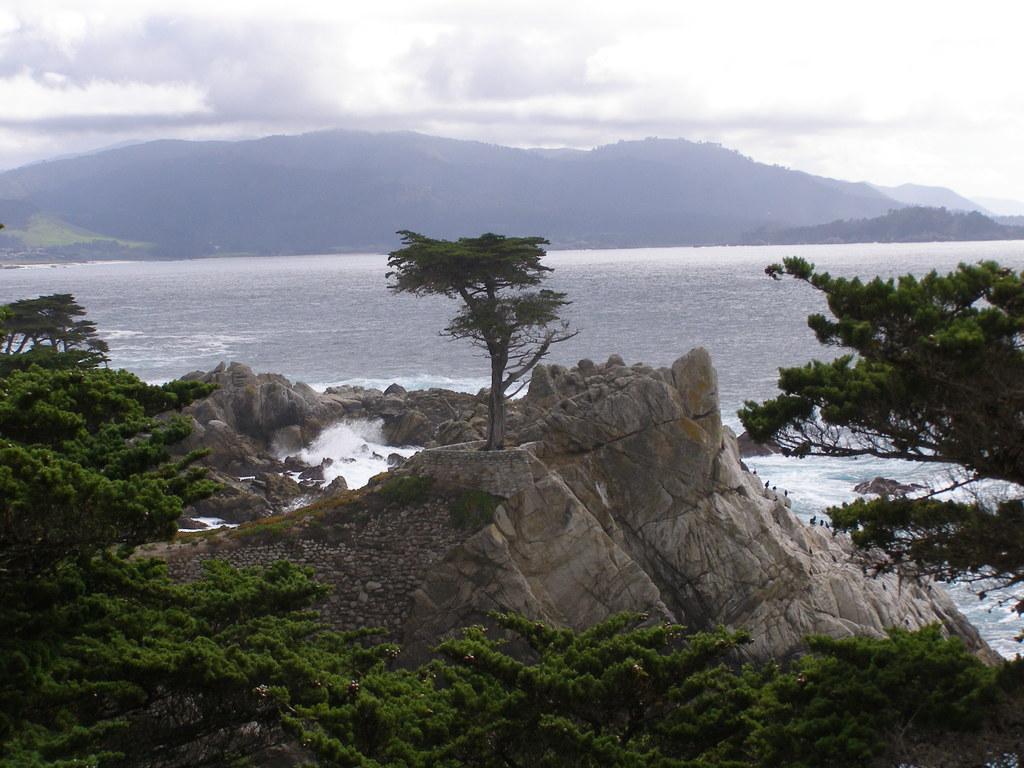How would you summarize this image in a sentence or two? At the bottom of the picture, we see the trees. In the middle of the picture, we see the rocks and a tree. On the right side, we see the trees. In the middle of the picture, we see water and this water might be in the sea. There are hills in the background. At the top, we see the sky. 